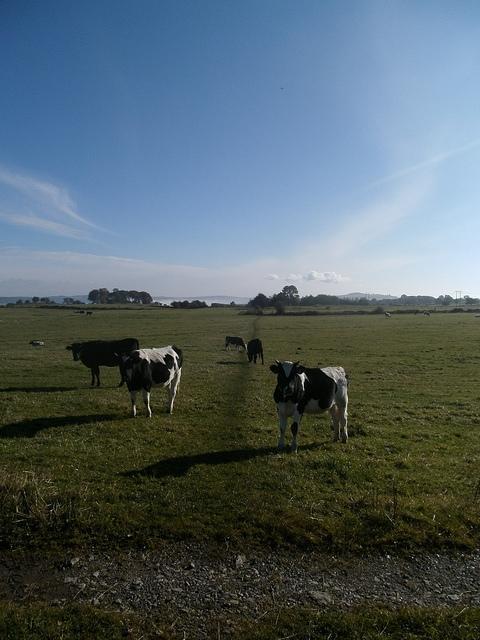How many of the cattle are not grazing?
Give a very brief answer. 3. How many cows are in the picture?
Give a very brief answer. 2. How many people wearing yellow shirts?
Give a very brief answer. 0. 